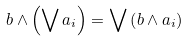<formula> <loc_0><loc_0><loc_500><loc_500>b \wedge \left ( \bigvee a _ { i } \right ) = \bigvee \left ( b \wedge a _ { i } \right )</formula> 